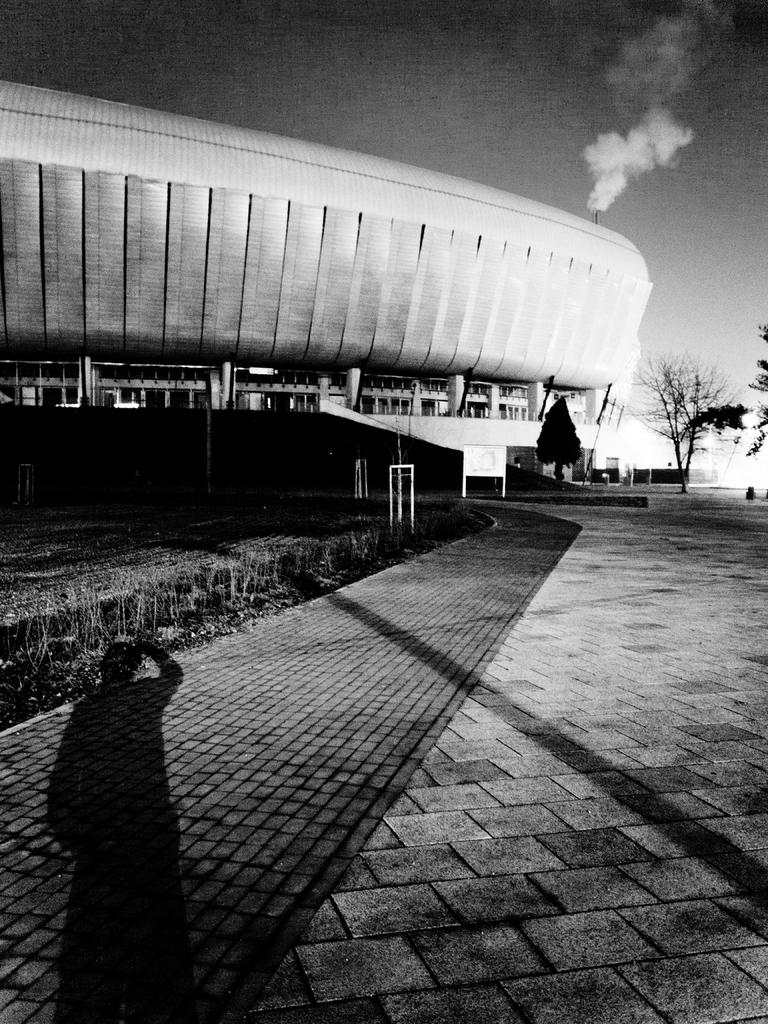What is the color scheme of the image? The image is black and white. What type of structure can be seen in the image? There is a building in the image. What natural elements are present in the image? There are trees in the image. Can you describe any human presence in the image? There is a shadow of a person in the image. What can be seen in the background of the image? There is smoke visible in the background of the image. How many sheep are visible in the image? There are no sheep present in the image. What type of boot is being twisted by the person in the image? There is no person or boot present in the image; only a shadow of a person is visible. 